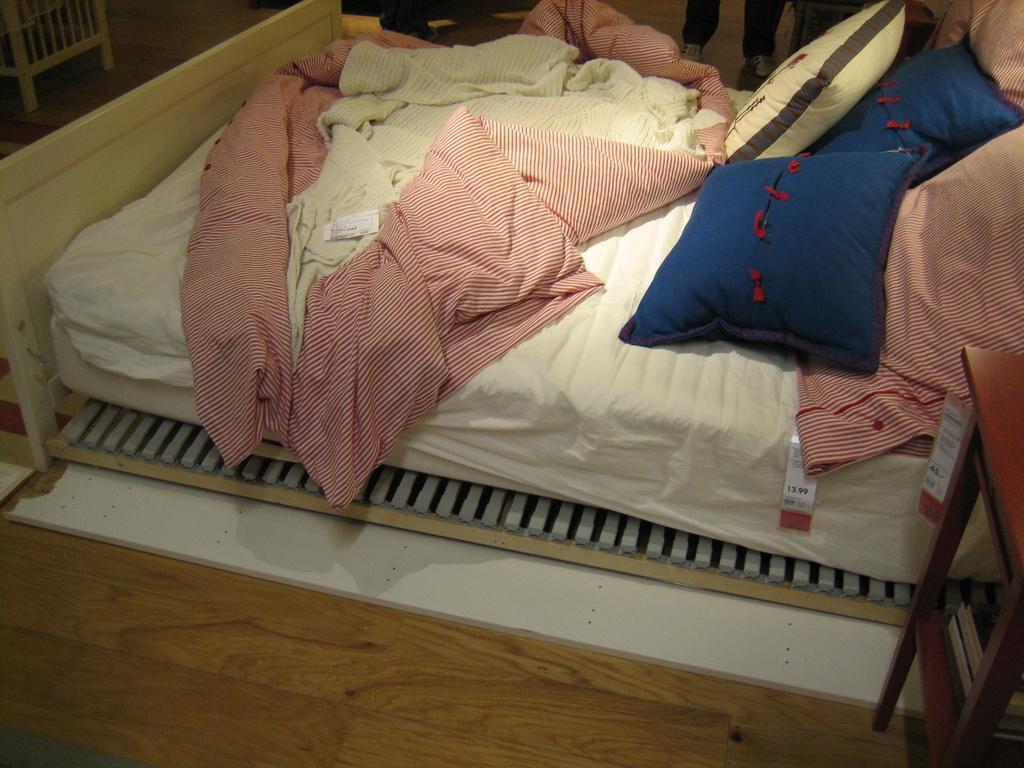How would you summarize this image in a sentence or two? This picture is clicked inside the room. here, we see a bed on which bed sheets, pink bed sheet and five pillows are placed. Among this five, two are blue in color and two are pink color and one is in white color. On the right bottom of the image, we see table and on the left top we see chair. 